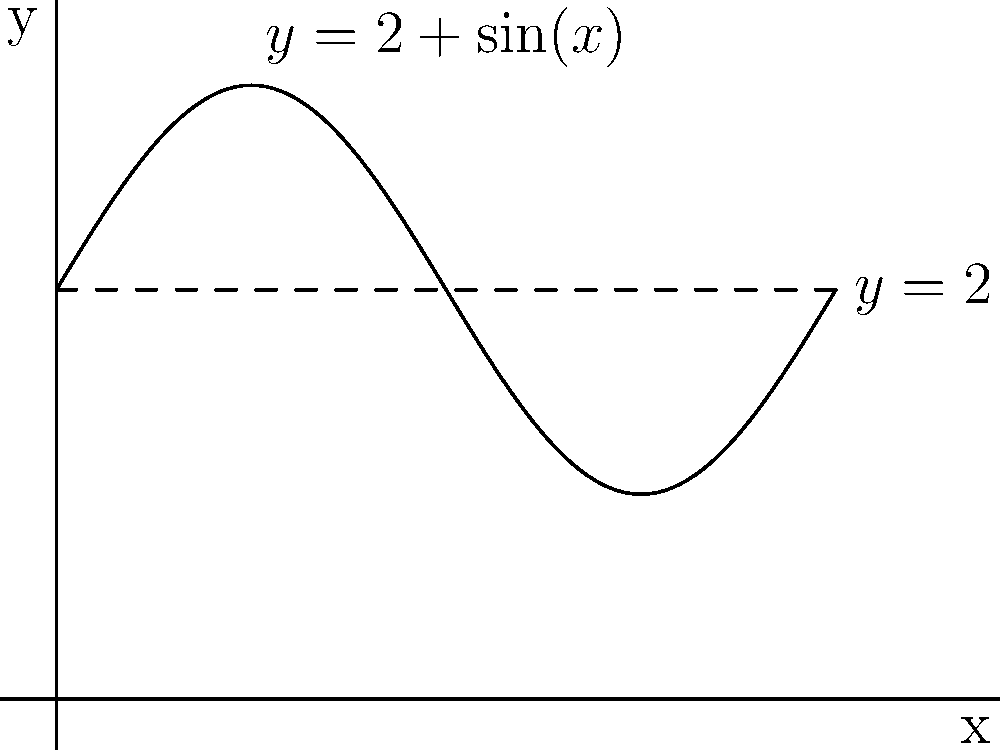Consider the function $f(x)=2+\sin(x)$ representing the GDP growth rate of EU countries over time, where $x$ is measured in years and $y$ in percentage points. If we rotate this function around the line $y=2$ from $x=0$ to $x=2\pi$, what is the volume of the resulting solid? (Use $\pi$ in your answer) To find the volume of the solid formed by rotating the given function around $y=2$, we'll use the washer method:

1) The area of each washer is given by $\pi(R^2-r^2)$, where $R$ is the outer radius and $r$ is the inner radius.

2) In this case, $R = f(x) - 2 = (2+\sin(x)) - 2 = \sin(x)$
   and $r = 0$ (since we're rotating around $y=2$)

3) The volume is given by the integral:
   $$V = \int_0^{2\pi} \pi(R^2-r^2) dx = \pi \int_0^{2\pi} (\sin^2(x) - 0^2) dx$$

4) Simplify: $V = \pi \int_0^{2\pi} \sin^2(x) dx$

5) We can use the identity $\sin^2(x) = \frac{1-\cos(2x)}{2}$:
   $$V = \pi \int_0^{2\pi} \frac{1-\cos(2x)}{2} dx$$

6) Integrate:
   $$V = \pi [\frac{x}{2} - \frac{\sin(2x)}{4}]_0^{2\pi}$$

7) Evaluate:
   $$V = \pi [\frac{2\pi}{2} - \frac{\sin(4\pi)}{4} - (0 - 0)] = \pi^2$$

Thus, the volume of the solid is $\pi^2$ cubic units.
Answer: $\pi^2$ cubic units 